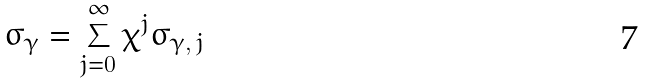Convert formula to latex. <formula><loc_0><loc_0><loc_500><loc_500>\sigma _ { \gamma } = \sum ^ { \infty } _ { j = 0 } \chi ^ { j } \sigma _ { \gamma , \, j }</formula> 